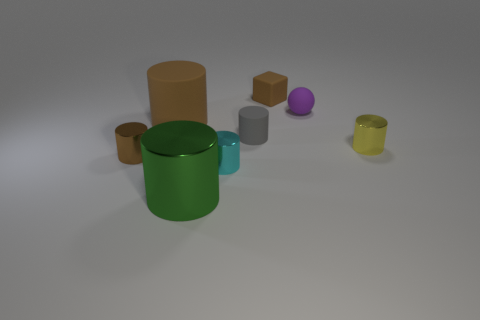Subtract all brown cylinders. How many cylinders are left? 4 Subtract all brown shiny cylinders. How many cylinders are left? 5 Subtract all purple cylinders. Subtract all yellow balls. How many cylinders are left? 6 Add 1 cyan matte things. How many objects exist? 9 Subtract all cylinders. How many objects are left? 2 Add 1 large brown matte things. How many large brown matte things are left? 2 Add 6 matte blocks. How many matte blocks exist? 7 Subtract 1 gray cylinders. How many objects are left? 7 Subtract all small metallic cylinders. Subtract all yellow rubber cylinders. How many objects are left? 5 